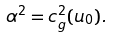Convert formula to latex. <formula><loc_0><loc_0><loc_500><loc_500>\alpha ^ { 2 } = c ^ { 2 } _ { g } ( u _ { 0 } ) .</formula> 